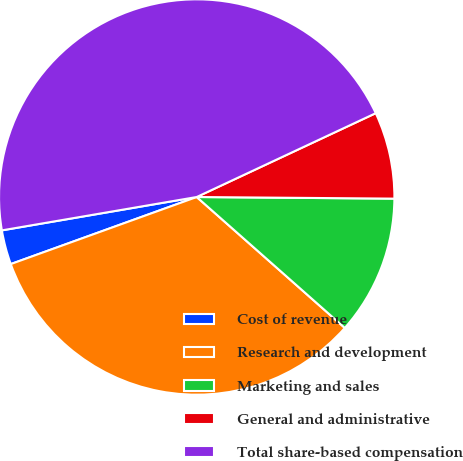Convert chart to OTSL. <chart><loc_0><loc_0><loc_500><loc_500><pie_chart><fcel>Cost of revenue<fcel>Research and development<fcel>Marketing and sales<fcel>General and administrative<fcel>Total share-based compensation<nl><fcel>2.81%<fcel>32.97%<fcel>11.39%<fcel>7.1%<fcel>45.73%<nl></chart> 